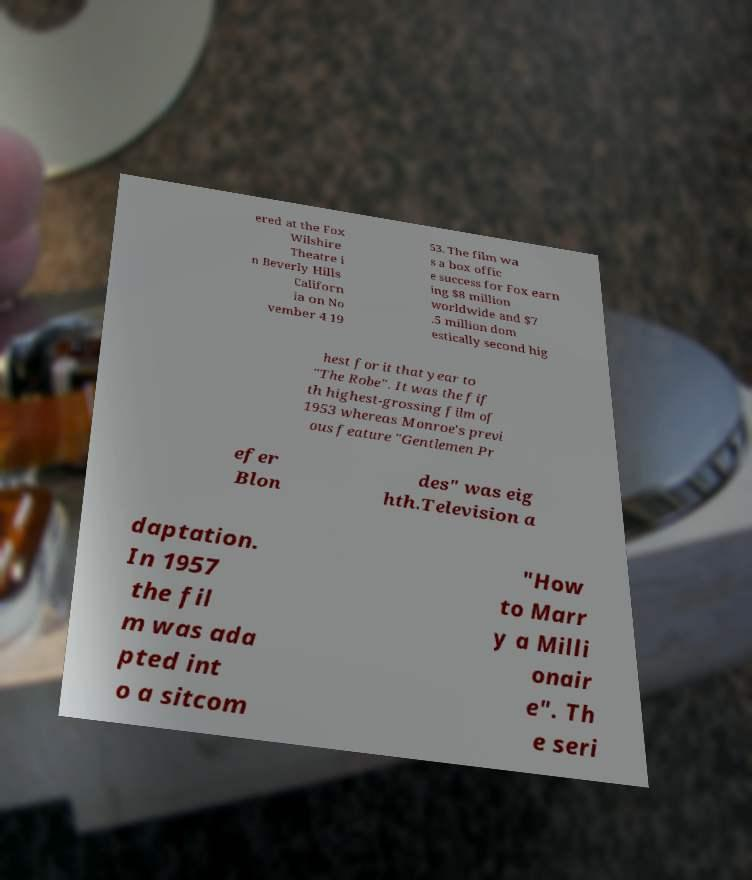Can you read and provide the text displayed in the image?This photo seems to have some interesting text. Can you extract and type it out for me? ered at the Fox Wilshire Theatre i n Beverly Hills Californ ia on No vember 4 19 53. The film wa s a box offic e success for Fox earn ing $8 million worldwide and $7 .5 million dom estically second hig hest for it that year to "The Robe". It was the fif th highest-grossing film of 1953 whereas Monroe's previ ous feature "Gentlemen Pr efer Blon des" was eig hth.Television a daptation. In 1957 the fil m was ada pted int o a sitcom "How to Marr y a Milli onair e". Th e seri 